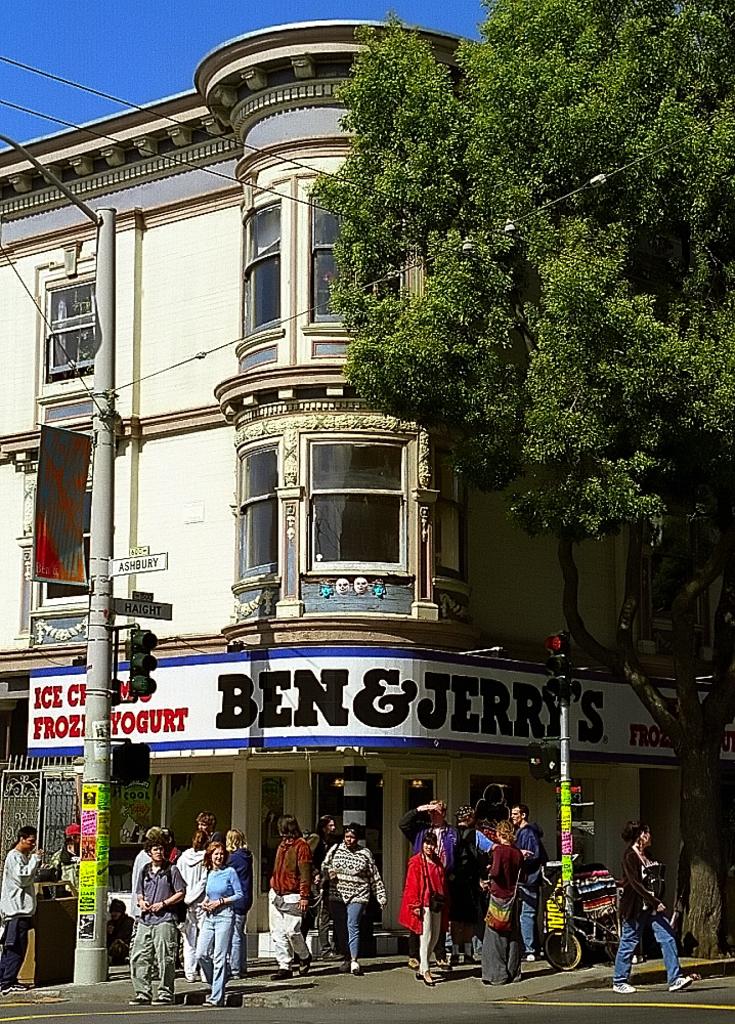What ice cream brand is this?
Ensure brevity in your answer.  Ben & jerry's. What else do they have besides ice cream?
Make the answer very short. Frozen yogurt. 